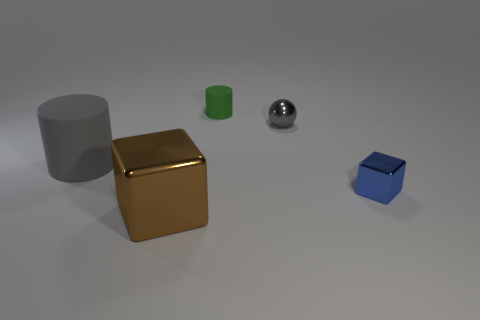What is the size of the object that is the same color as the big cylinder?
Ensure brevity in your answer.  Small. How many tiny green cylinders are made of the same material as the large cylinder?
Provide a succinct answer. 1. What is the size of the rubber cylinder that is to the right of the rubber cylinder left of the green matte thing?
Ensure brevity in your answer.  Small. Is there a brown shiny thing of the same shape as the big gray thing?
Offer a terse response. No. There is a rubber object that is behind the small gray metallic ball; does it have the same size as the rubber cylinder that is to the left of the tiny rubber cylinder?
Ensure brevity in your answer.  No. Is the number of small green cylinders that are in front of the green cylinder less than the number of small green matte things on the right side of the tiny gray ball?
Make the answer very short. No. There is a thing that is the same color as the ball; what material is it?
Your answer should be very brief. Rubber. What is the color of the large object that is behind the large shiny object?
Ensure brevity in your answer.  Gray. Does the large rubber thing have the same color as the small shiny ball?
Your answer should be very brief. Yes. What number of small objects are behind the big gray matte thing that is on the left side of the big metal block that is in front of the tiny blue object?
Your answer should be compact. 2. 